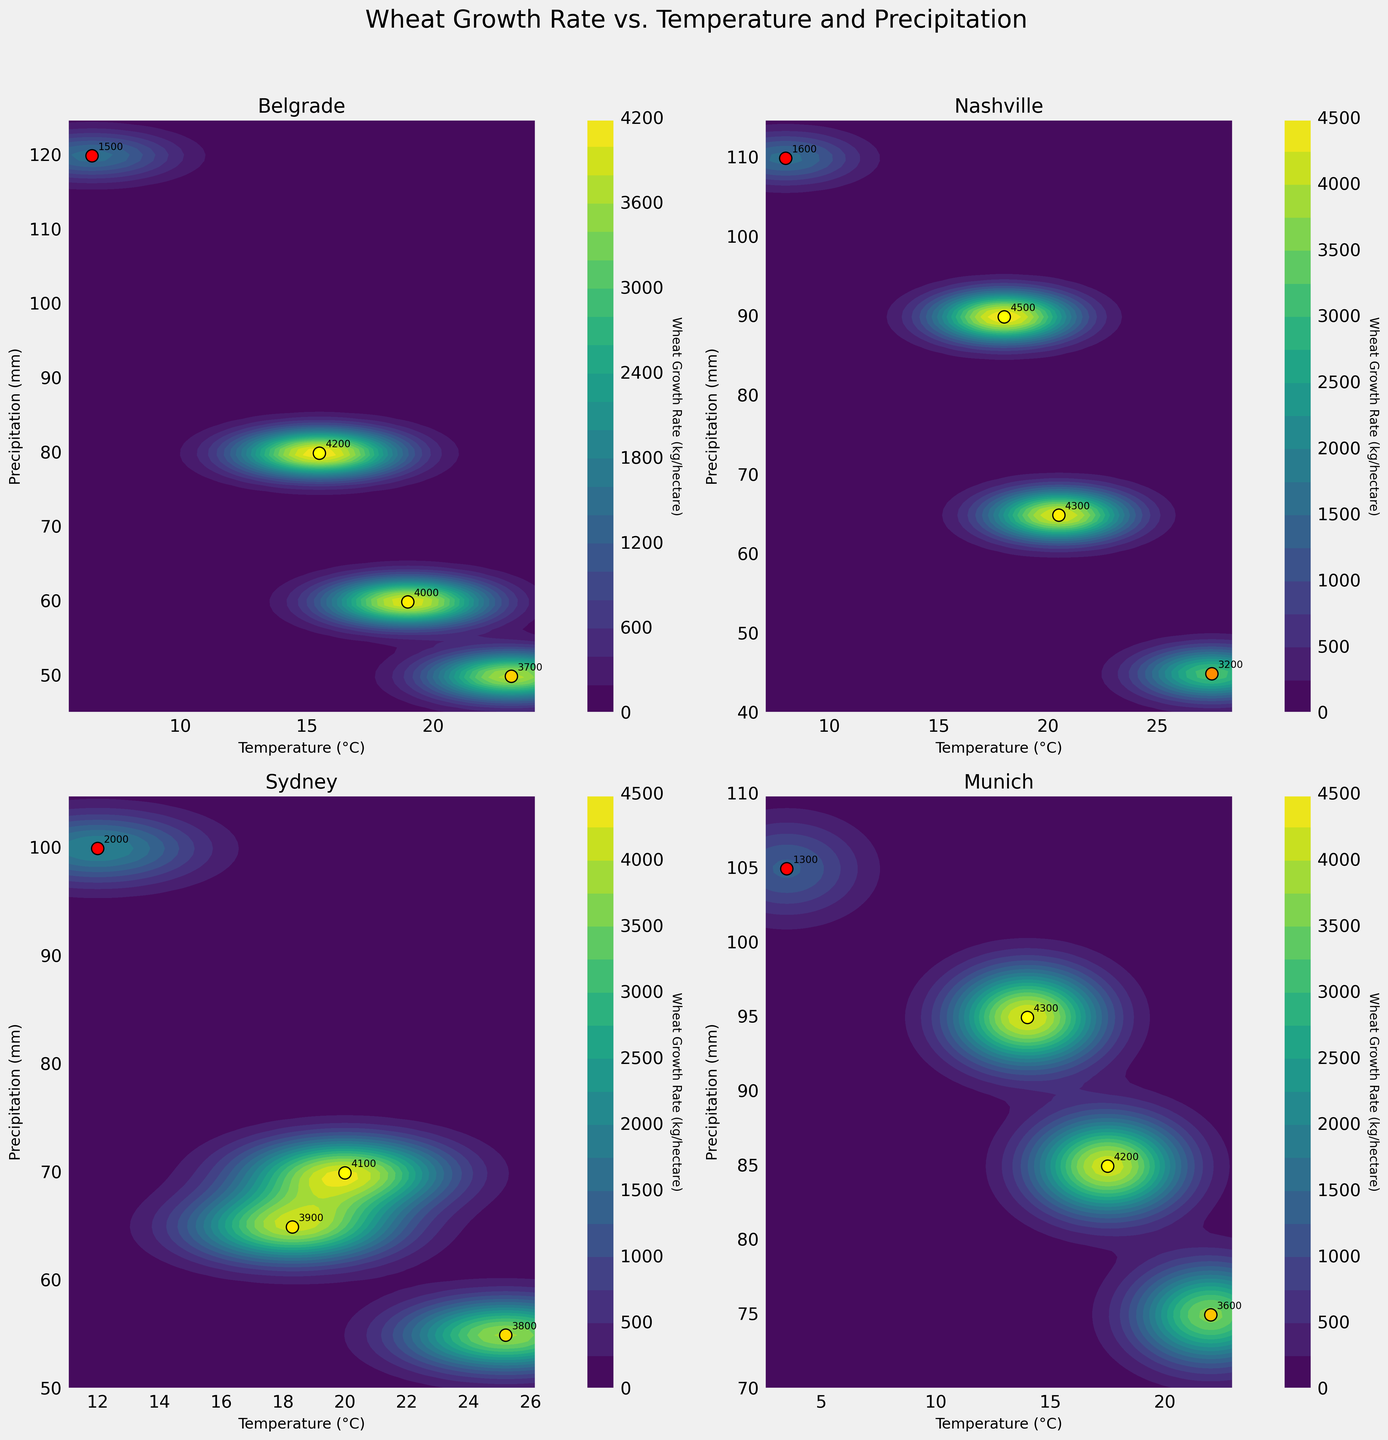What's the title of the figure? The title of the figure is positioned at the top and is often in a larger, bold font to make it stand out. In this figure, it is "Wheat Growth Rate vs. Temperature and Precipitation".
Answer: Wheat Growth Rate vs. Temperature and Precipitation Which location has the highest wheat growth rate in Spring? By looking at the scatter points and annotations in the subplots, we see that Nashville has the highest wheat growth rate in Spring with a value of 4500 kg/hectare.
Answer: Nashville How does precipitation in Winter differ between Belgrade and Sydney? By observing the Winter scatter points and their corresponding precipitation values in the subplots for Belgrade and Sydney, we see that Belgrade has 120 mm and Sydney has 100 mm of precipitation in Winter, so the difference is 20 mm.
Answer: 20 mm Which season in Munich has the lowest wheat growth rate and what is the value? From the Munich subplot, the Winter scatter point shows the lowest wheat growth rate, which is annotated as 1300 kg/hectare.
Answer: Winter; 1300 kg/hectare What is the relationship between temperature and wheat growth rate in Summer for Nashville? In Nashville's subplot, observing the Summer scatter point and its annotated values, we see that a higher temperature of 27.5°C corresponds to a lower wheat growth rate of 3200 kg/hectare. This suggests an inverse relationship between temperature and wheat growth rate in Summer.
Answer: Inverse relationship Compare the wheat growth rates between Spring and Autumn in Belgrade. Which season has a higher rate and by how much? Referring to the scatter points and annotations in Belgrade's subplot, Spring has a wheat growth rate of 4200 kg/hectare and Autumn has 4000 kg/hectare. Spring has a higher rate by 200 kg/hectare.
Answer: Spring; 200 kg/hectare In which season do all locations, except Munich, experience their highest precipitation levels? By analyzing precipitation values and comparing them across all seasons for each location in the subplots, it's shown that Winter has the highest precipitation levels for Belgrade, Nashville, and Sydney.
Answer: Winter How does the growth rate in Sydney's Summer compare to the growth rate in Munich's Summer? Observing the Summer scatter points and annotations for both Sydney and Munich subplots, Sydney has a wheat growth rate of 3800 kg/hectare, whereas Munich has 3600 kg/hectare. Sydney's growth rate in Summer is higher by 200 kg/hectare.
Answer: Sydney is higher by 200 kg/hectare What's the average wheat growth rate across all seasons for Belgrade? By adding together Belgrade’s wheat growth rates across Spring (4200), Summer (3700), Autumn (4000), and Winter (1500) and then dividing by 4, we get an average growth rate: (4200 + 3700 + 4000 + 1500) / 4 = 3350 kg/hectare.
Answer: 3350 kg/hectare Which location displays the least variation in wheat growth rates across different seasons? By comparing the scatter points and annotations for all seasons in each subplot, Sydney shows the least variation in wheat growth rates, with values ranging from 2000 to 4100 kg/hectare across Spring, Summer, Autumn, and Winter.
Answer: Sydney 